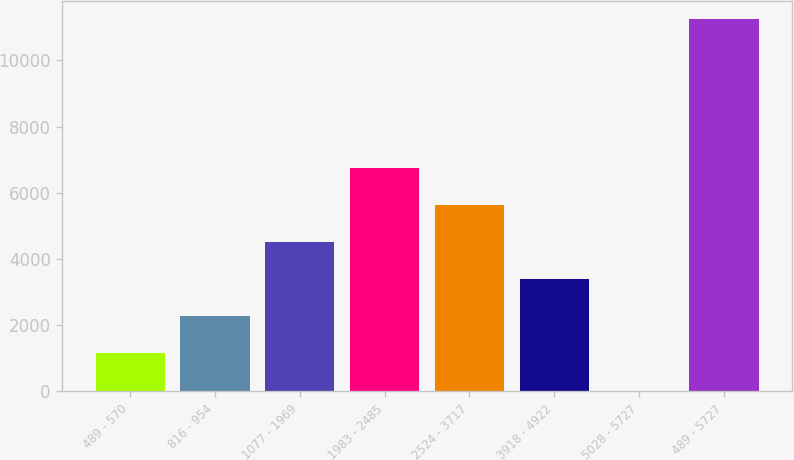<chart> <loc_0><loc_0><loc_500><loc_500><bar_chart><fcel>489 - 570<fcel>816 - 954<fcel>1077 - 1969<fcel>1983 - 2485<fcel>2524 - 3717<fcel>3918 - 4922<fcel>5028 - 5727<fcel>489 - 5727<nl><fcel>1133.6<fcel>2257.2<fcel>4504.4<fcel>6751.6<fcel>5628<fcel>3380.8<fcel>10<fcel>11246<nl></chart> 